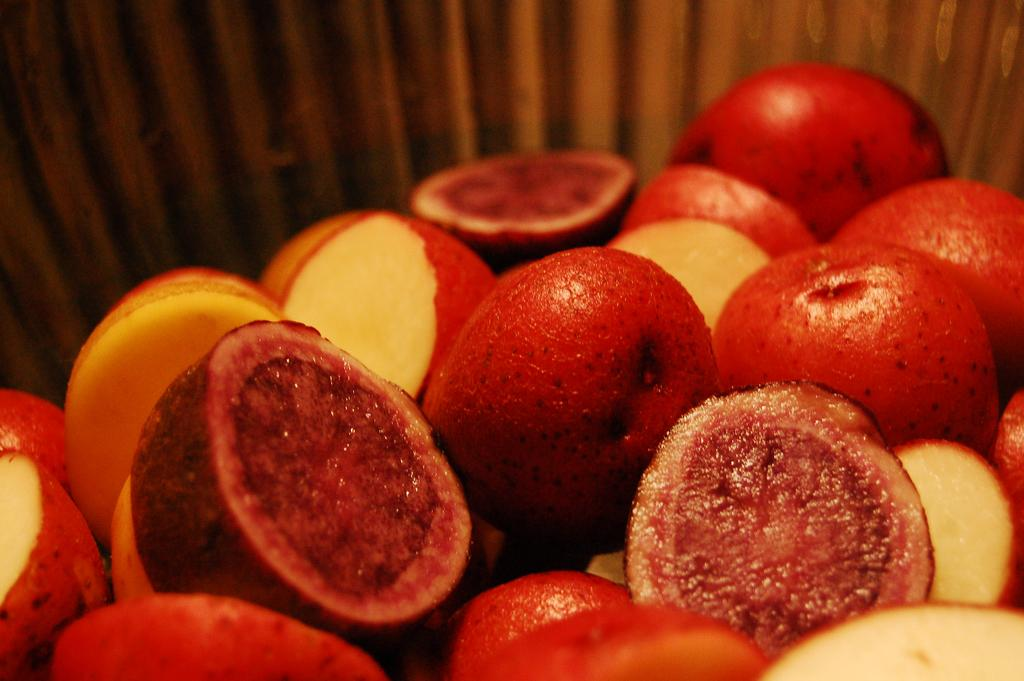What type of food is present in the image? There are fruits in the image. How are the fruits prepared? The fruits are cut into slices. What color are the fruits in the image? The fruits are red in color. Can you describe the background of the image? There is a wooden object in the backdrop of the image, but it is blurred. What type of jelly is being used to plot a trip in the image? There is no jelly or trip being plotted in the image; it features sliced red fruits and a blurred wooden object in the background. 